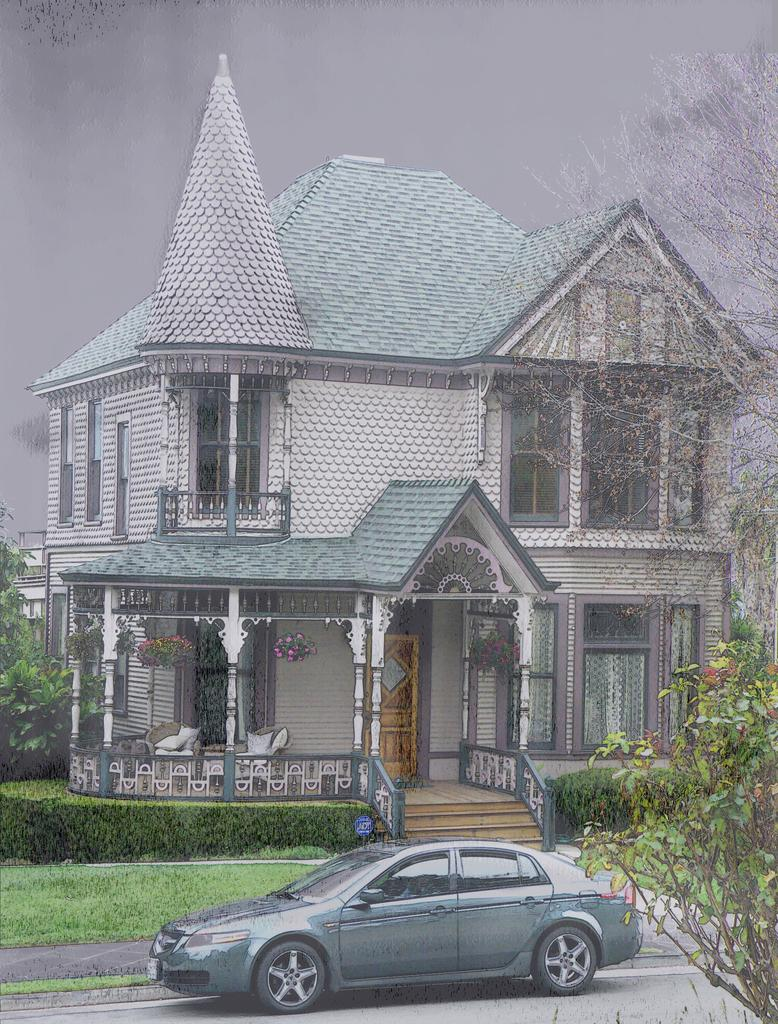What is the main subject of the image? There is a car in the image. Where is the car located in relation to the house? The car is parked in front of a house. What type of natural environment is visible around the house? Trees are present around the house, and there is greenery in the image. How would you describe the weather based on the appearance of the sky? The sky appears gloomy in the image. Can you see a river flowing near the car in the image? No, there is no river visible in the image. What type of game is being played by the people in the image? There are no people or games present in the image; it features a car parked in front of a house. 